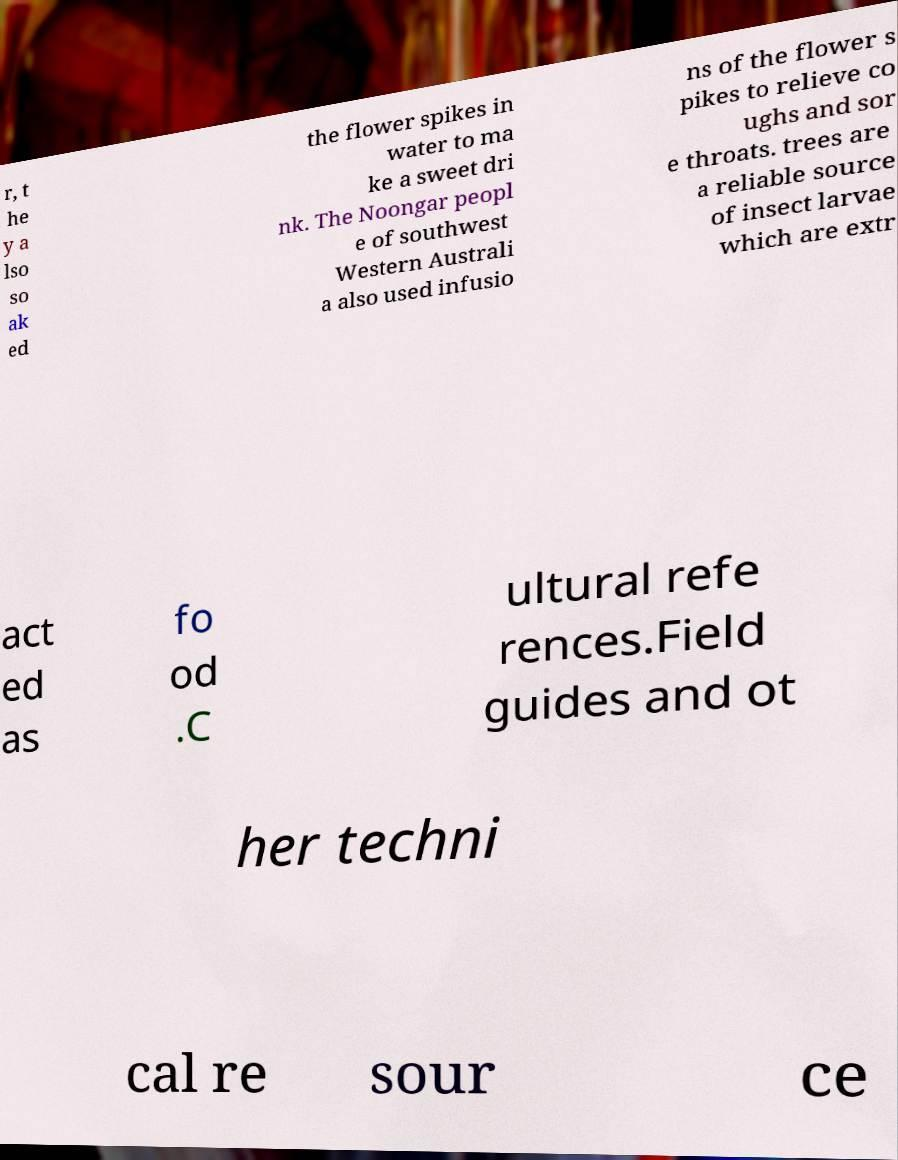Please read and relay the text visible in this image. What does it say? r, t he y a lso so ak ed the flower spikes in water to ma ke a sweet dri nk. The Noongar peopl e of southwest Western Australi a also used infusio ns of the flower s pikes to relieve co ughs and sor e throats. trees are a reliable source of insect larvae which are extr act ed as fo od .C ultural refe rences.Field guides and ot her techni cal re sour ce 